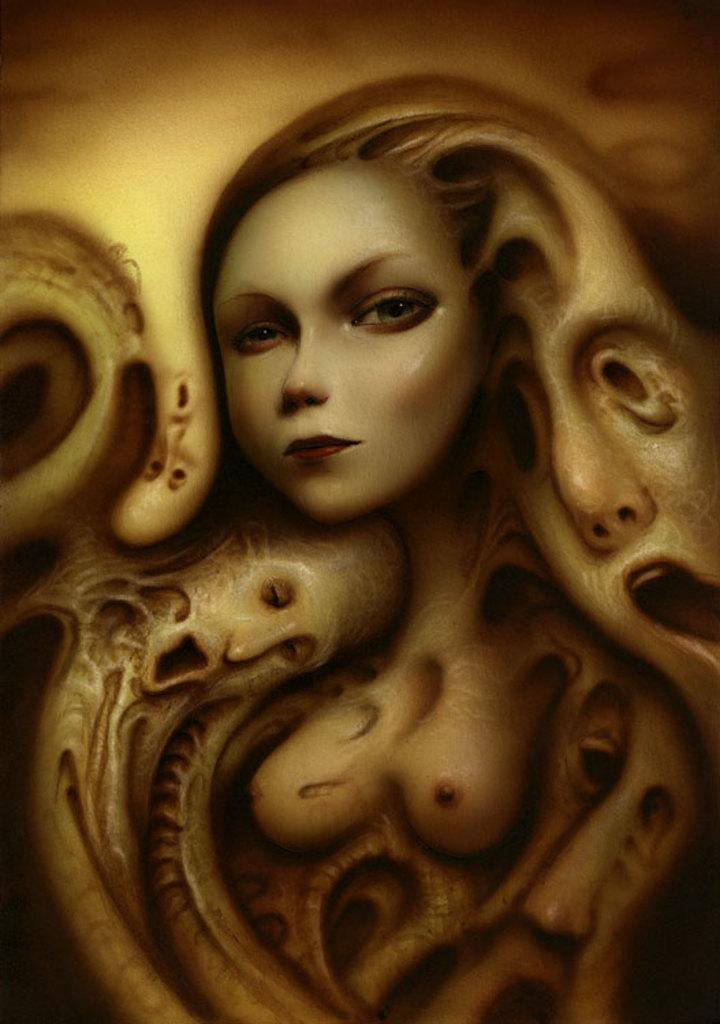What is the main subject of the painting in the image? The main subject of the painting in the image is a woman. Can you describe any other elements in the painting? Faces of people are visible in the image. What type of meat is being served on the page in the image? There is no meat or page present in the image; it features a painting of a woman with faces of people visible. 